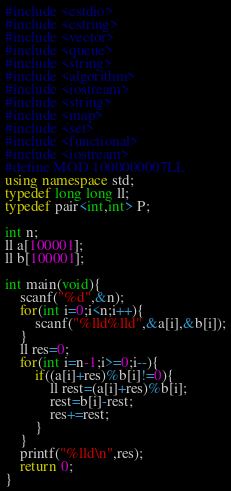Convert code to text. <code><loc_0><loc_0><loc_500><loc_500><_C++_>#include <cstdio>
#include <cstring>
#include <vector>
#include <queue>
#include <string>
#include <algorithm>
#include <iostream>
#include <string>
#include <map>
#include <set>
#include <functional>
#include <iostream>
#define MOD 1000000007LL
using namespace std;
typedef long long ll;
typedef pair<int,int> P;

int n;
ll a[100001];
ll b[100001];

int main(void){
	scanf("%d",&n);
	for(int i=0;i<n;i++){
		scanf("%lld%lld",&a[i],&b[i]);
	}
	ll res=0;
	for(int i=n-1;i>=0;i--){
		if((a[i]+res)%b[i]!=0){
			ll rest=(a[i]+res)%b[i];
			rest=b[i]-rest;
			res+=rest;
		}
	}
	printf("%lld\n",res);
	return 0;
}
</code> 